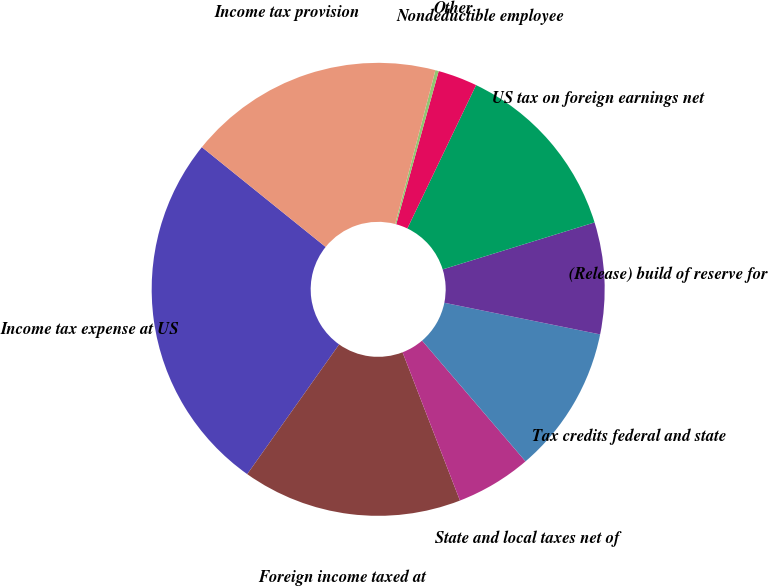Convert chart. <chart><loc_0><loc_0><loc_500><loc_500><pie_chart><fcel>Income tax expense at US<fcel>Foreign income taxed at<fcel>State and local taxes net of<fcel>Tax credits federal and state<fcel>(Release) build of reserve for<fcel>US tax on foreign earnings net<fcel>Nondeductible employee<fcel>Other<fcel>Income tax provision<nl><fcel>25.99%<fcel>15.69%<fcel>5.39%<fcel>10.54%<fcel>7.96%<fcel>13.11%<fcel>2.81%<fcel>0.24%<fcel>18.26%<nl></chart> 